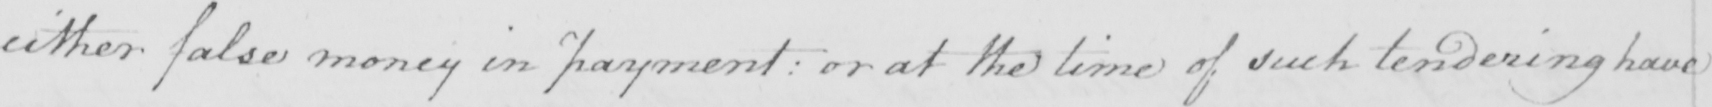What does this handwritten line say? either false money in payment :  or at the time of such tendering have 